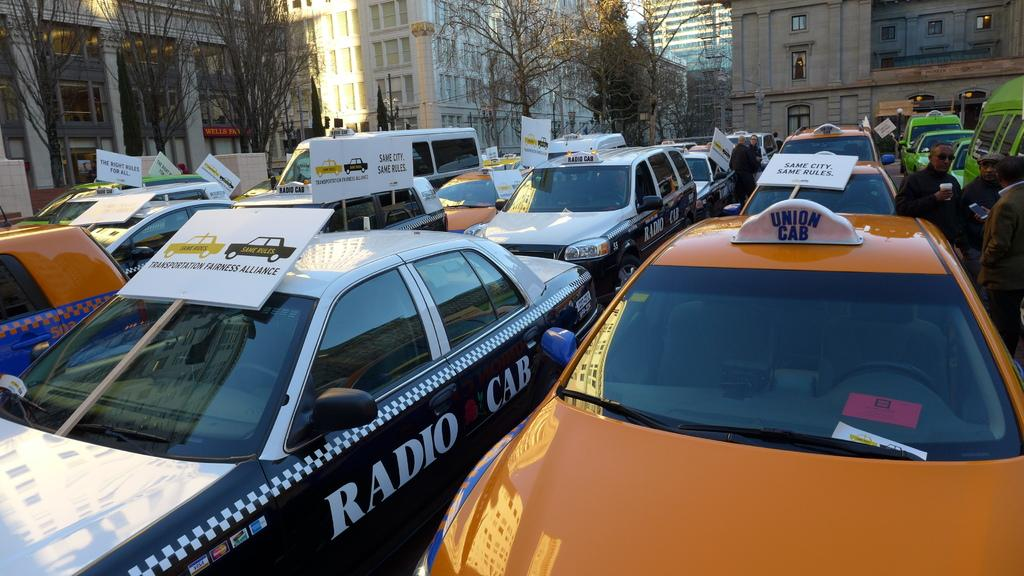Provide a one-sentence caption for the provided image. A group of cabs lined up with signs citing fairness and rules. 